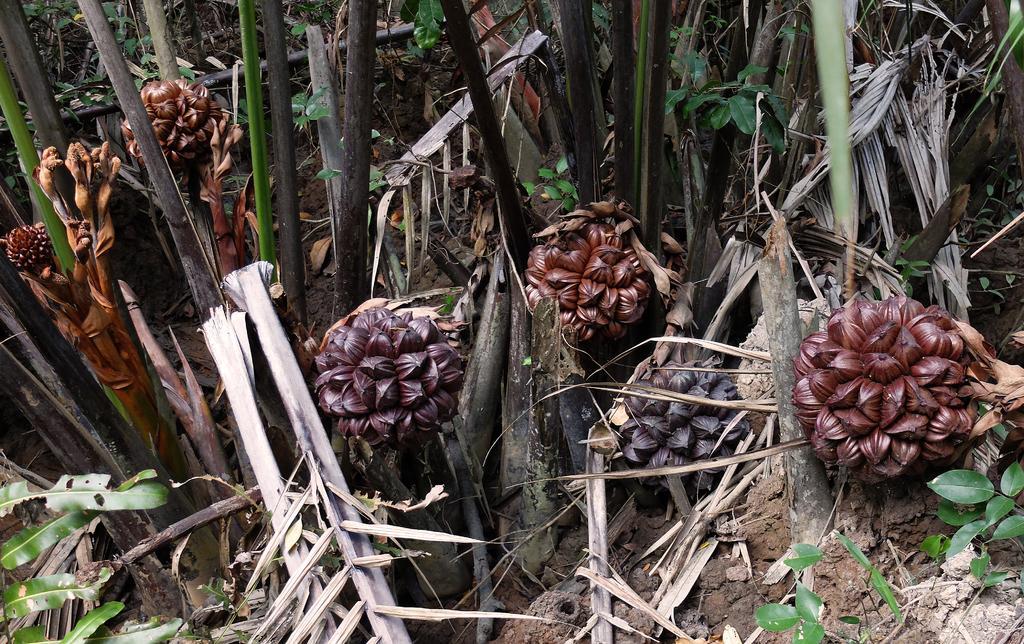Please provide a concise description of this image. In this picture we can see trees on the ground. 